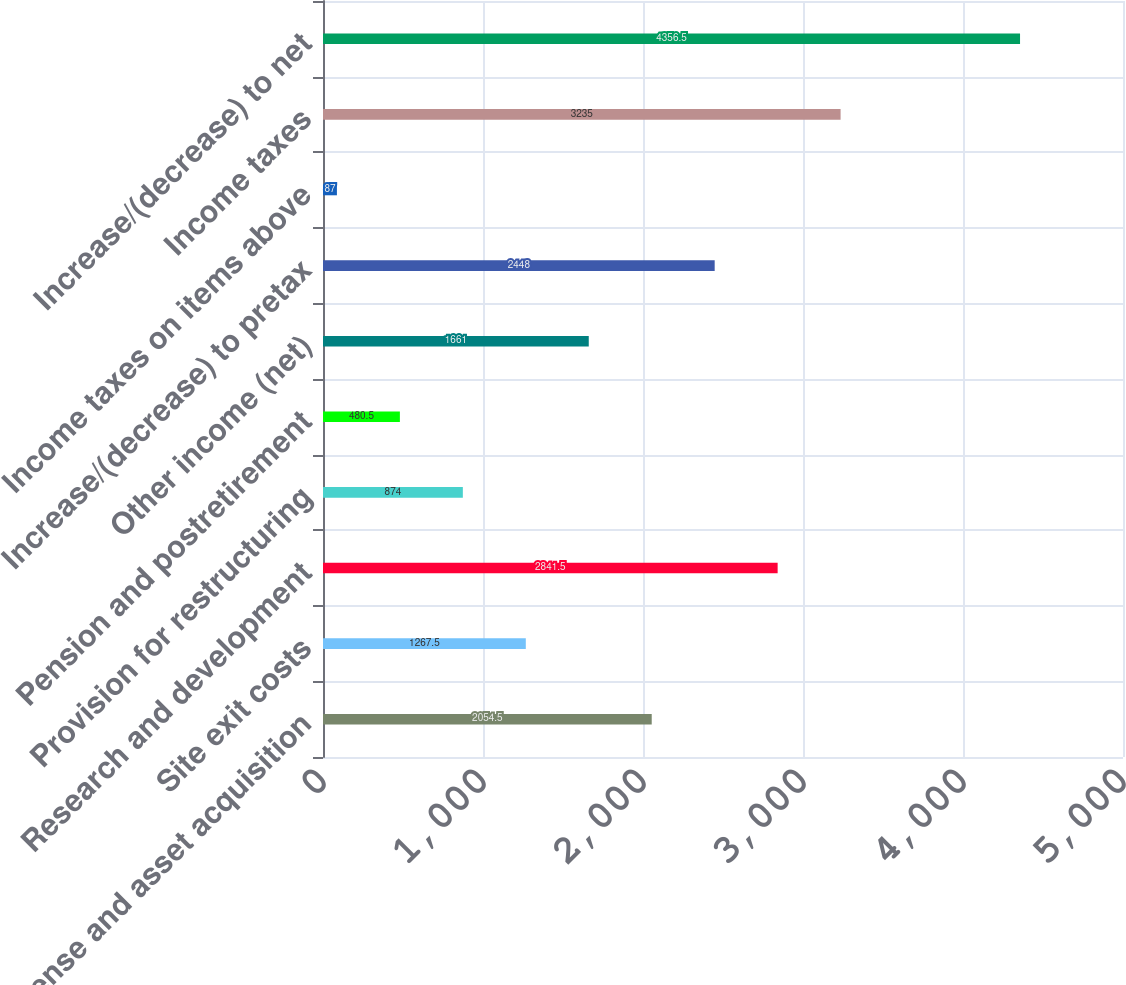<chart> <loc_0><loc_0><loc_500><loc_500><bar_chart><fcel>License and asset acquisition<fcel>Site exit costs<fcel>Research and development<fcel>Provision for restructuring<fcel>Pension and postretirement<fcel>Other income (net)<fcel>Increase/(decrease) to pretax<fcel>Income taxes on items above<fcel>Income taxes<fcel>Increase/(decrease) to net<nl><fcel>2054.5<fcel>1267.5<fcel>2841.5<fcel>874<fcel>480.5<fcel>1661<fcel>2448<fcel>87<fcel>3235<fcel>4356.5<nl></chart> 